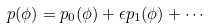Convert formula to latex. <formula><loc_0><loc_0><loc_500><loc_500>p ( \phi ) = p _ { 0 } ( \phi ) + \epsilon p _ { 1 } ( \phi ) + \cdots</formula> 